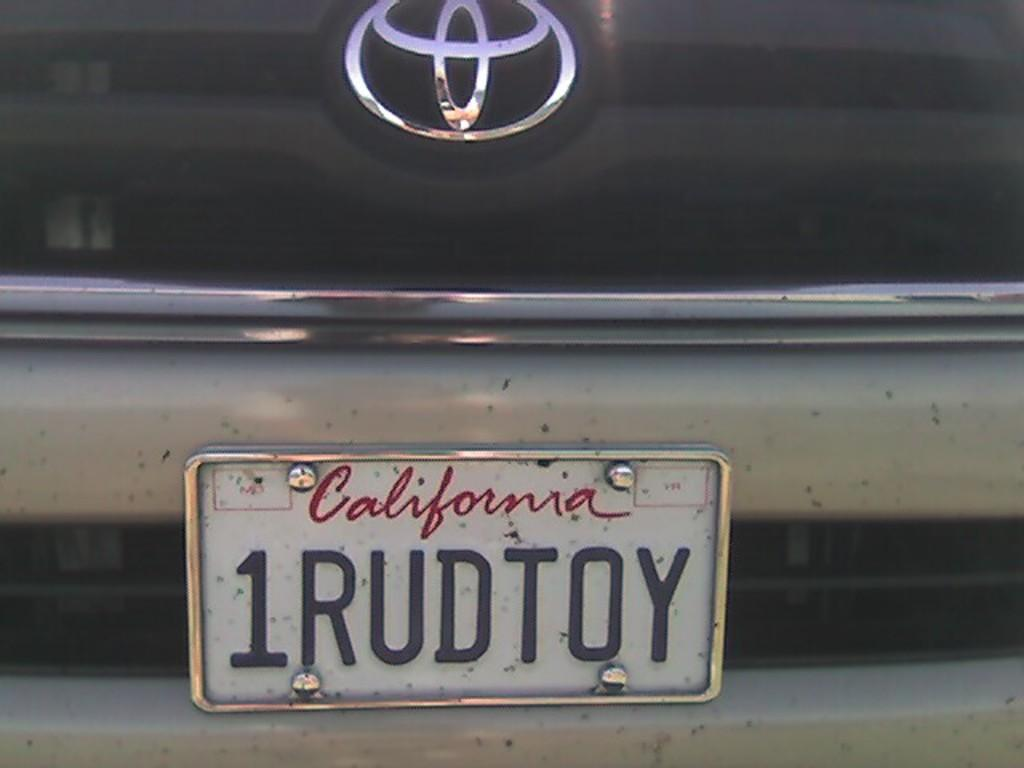<image>
Render a clear and concise summary of the photo. A car with a California license plate that reads 1RUDTOY. 